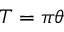Convert formula to latex. <formula><loc_0><loc_0><loc_500><loc_500>T = \pi \theta</formula> 